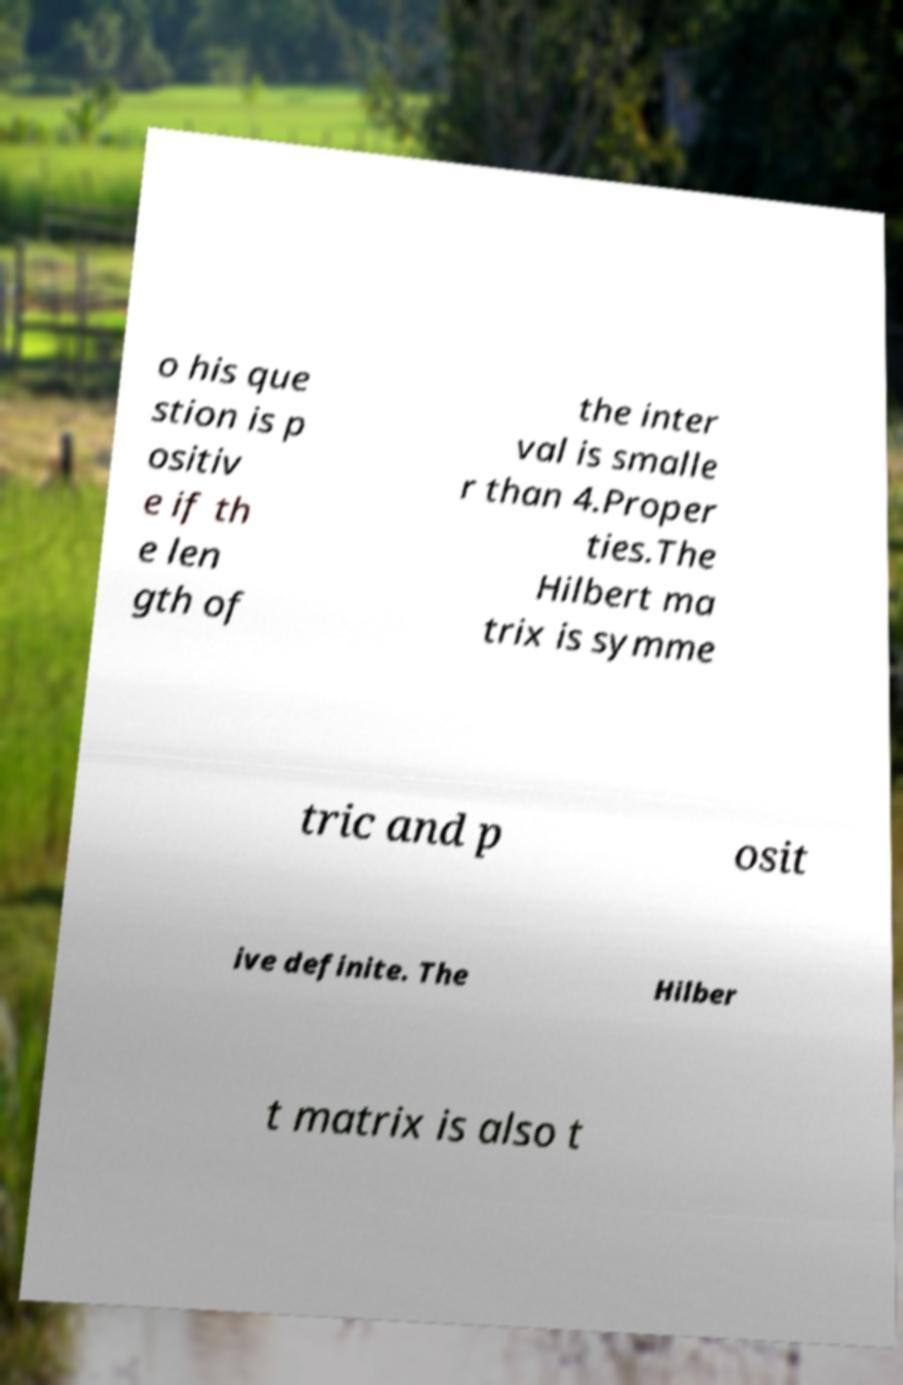I need the written content from this picture converted into text. Can you do that? o his que stion is p ositiv e if th e len gth of the inter val is smalle r than 4.Proper ties.The Hilbert ma trix is symme tric and p osit ive definite. The Hilber t matrix is also t 